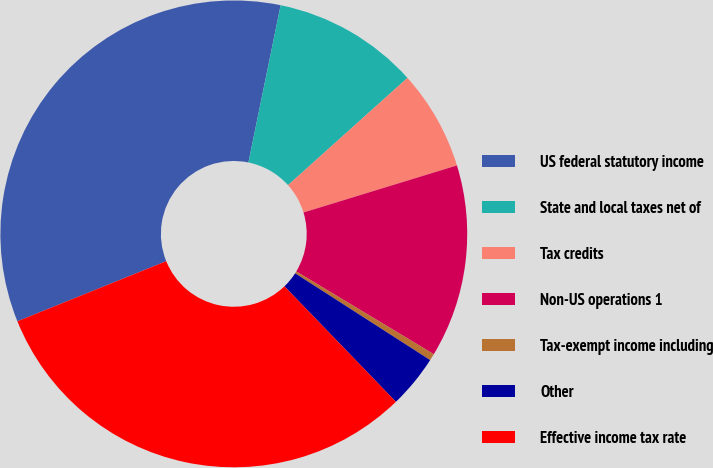<chart> <loc_0><loc_0><loc_500><loc_500><pie_chart><fcel>US federal statutory income<fcel>State and local taxes net of<fcel>Tax credits<fcel>Non-US operations 1<fcel>Tax-exempt income including<fcel>Other<fcel>Effective income tax rate<nl><fcel>34.33%<fcel>10.14%<fcel>6.91%<fcel>13.36%<fcel>0.47%<fcel>3.69%<fcel>31.11%<nl></chart> 